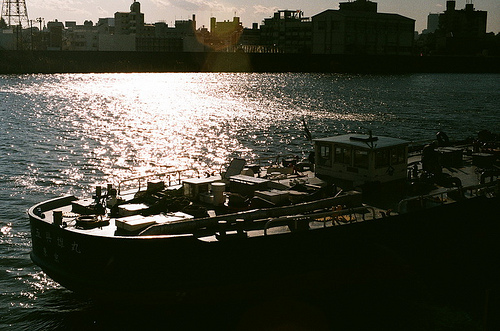What time of day does this scene depict? The scene appears to be set in the late afternoon or early evening, given the position and golden hue of the sunlight shining on the water. 